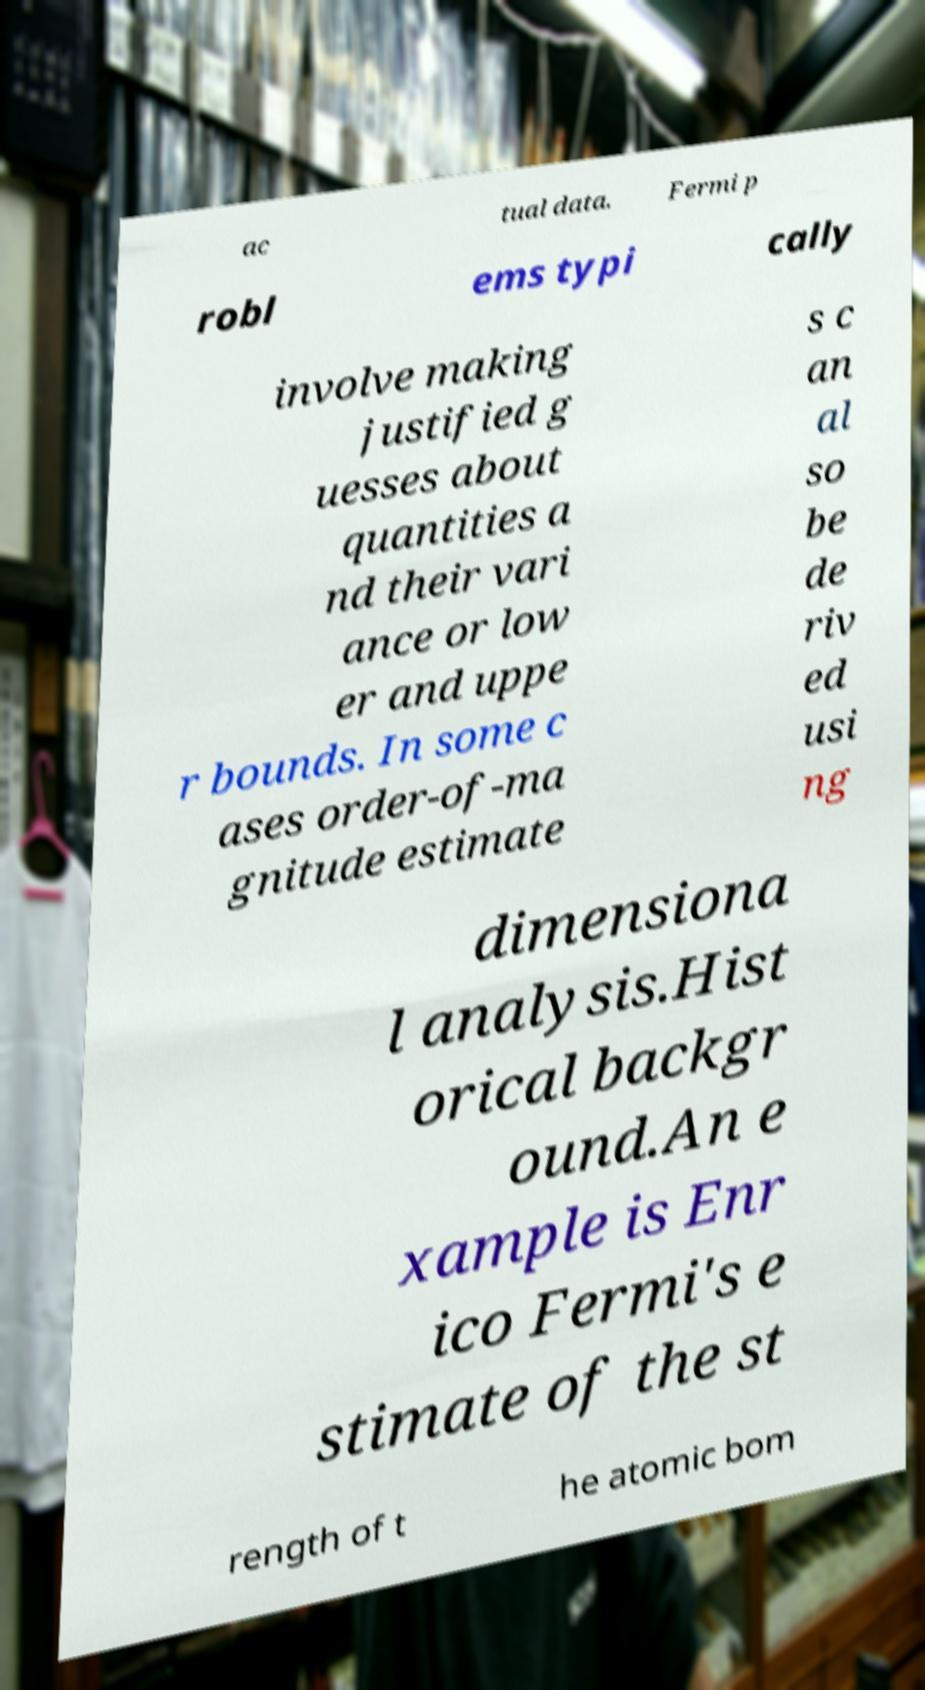Could you assist in decoding the text presented in this image and type it out clearly? ac tual data. Fermi p robl ems typi cally involve making justified g uesses about quantities a nd their vari ance or low er and uppe r bounds. In some c ases order-of-ma gnitude estimate s c an al so be de riv ed usi ng dimensiona l analysis.Hist orical backgr ound.An e xample is Enr ico Fermi's e stimate of the st rength of t he atomic bom 